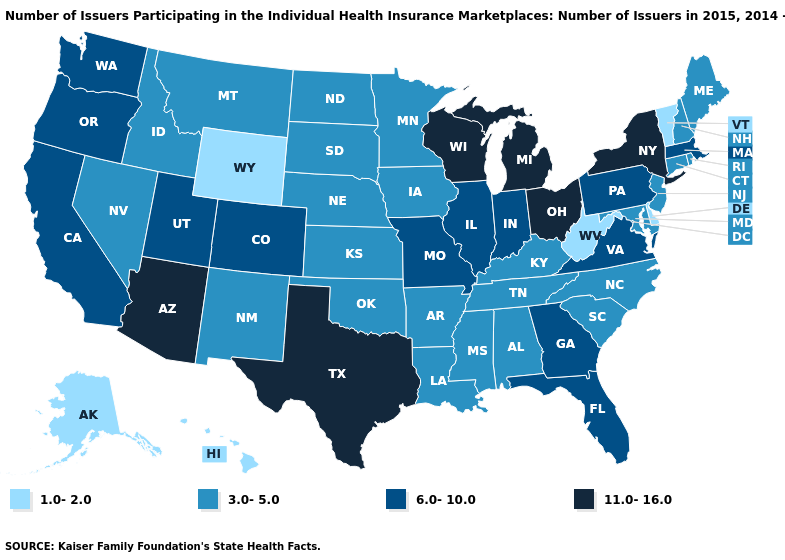Does the first symbol in the legend represent the smallest category?
Write a very short answer. Yes. What is the lowest value in the South?
Give a very brief answer. 1.0-2.0. Which states have the lowest value in the USA?
Short answer required. Alaska, Delaware, Hawaii, Vermont, West Virginia, Wyoming. Does Colorado have the same value as Texas?
Write a very short answer. No. How many symbols are there in the legend?
Keep it brief. 4. What is the lowest value in states that border California?
Short answer required. 3.0-5.0. What is the highest value in the Northeast ?
Write a very short answer. 11.0-16.0. Among the states that border Arkansas , which have the lowest value?
Write a very short answer. Louisiana, Mississippi, Oklahoma, Tennessee. Name the states that have a value in the range 11.0-16.0?
Quick response, please. Arizona, Michigan, New York, Ohio, Texas, Wisconsin. What is the value of Louisiana?
Short answer required. 3.0-5.0. Name the states that have a value in the range 6.0-10.0?
Give a very brief answer. California, Colorado, Florida, Georgia, Illinois, Indiana, Massachusetts, Missouri, Oregon, Pennsylvania, Utah, Virginia, Washington. What is the value of South Carolina?
Keep it brief. 3.0-5.0. What is the highest value in the USA?
Concise answer only. 11.0-16.0. Is the legend a continuous bar?
Quick response, please. No. Does Florida have a lower value than Wyoming?
Answer briefly. No. 